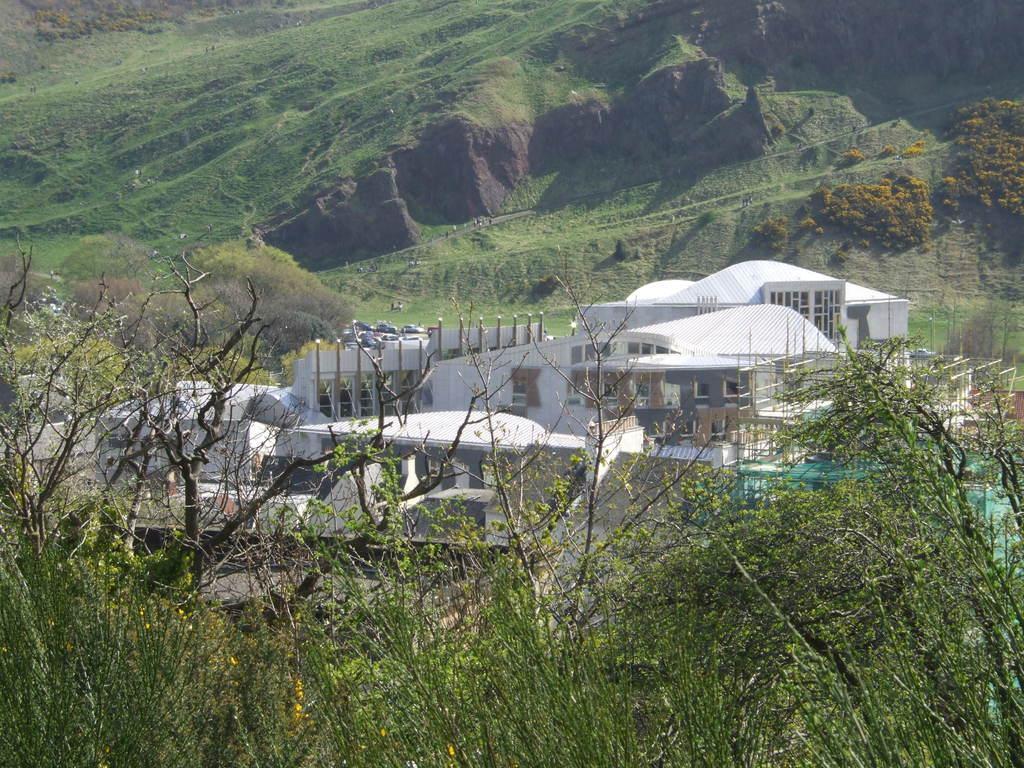Can you describe this image briefly? In this image I can see the plates and I can some yellow color flowers to it. To the side I can see the building which is in white color. In the background I can see the mountains. 